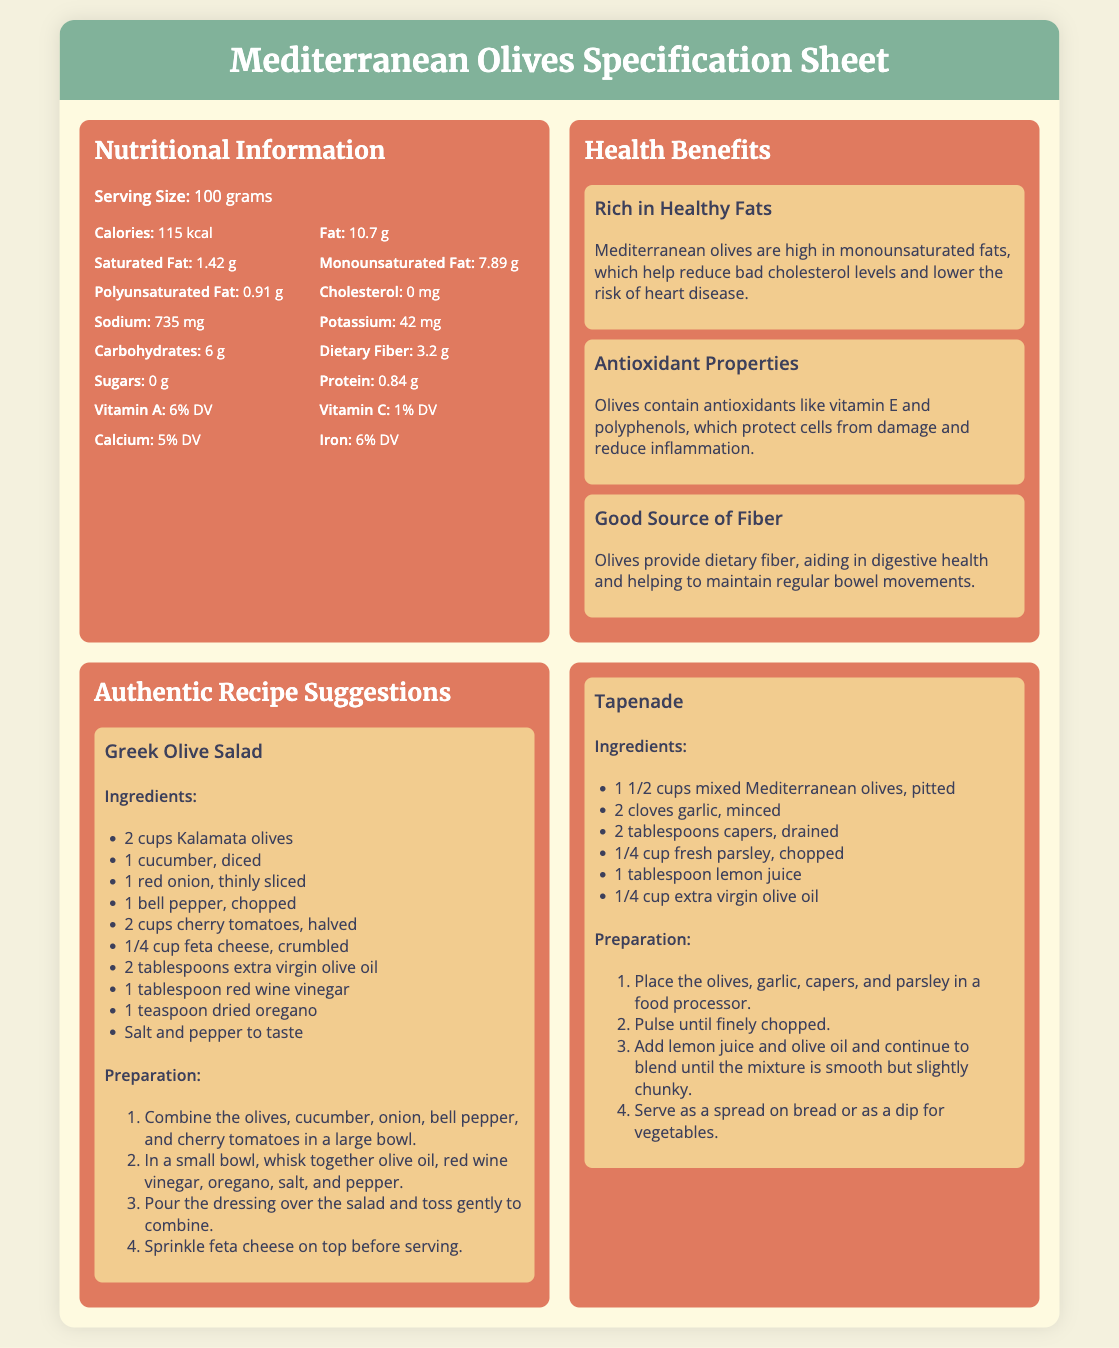what is the serving size? The serving size is specified in the document, which states it as 100 grams.
Answer: 100 grams how many calories are in 100 grams of olives? The document mentions the caloric content, which is 115 kcal per serving.
Answer: 115 kcal what is the sodium content in 100 grams of olives? The sodium content is listed in the nutritional information as 735 mg.
Answer: 735 mg what are two health benefits of Mediterranean olives? The document highlights multiple health benefits; two are reducing bad cholesterol and providing antioxidants.
Answer: Reducing bad cholesterol, providing antioxidants what is the main ingredient in Greek Olive Salad? The key ingredient is emphasized in the ingredient list, which starts with 2 cups Kalamata olives.
Answer: 2 cups Kalamata olives how many grams of protein are in 100 grams of olives? The protein content is provided in the nutritional information, noted as 0.84 g.
Answer: 0.84 g what dish requires mixed Mediterranean olives? The dish that specifically requires mixed Mediterranean olives is Tapenade.
Answer: Tapenade how many types of olives are mentioned in this specification sheet? The document includes references to two specific types: Kalamata olives and mixed Mediterranean olives.
Answer: Two types how does the document categorize information? The document is structured into categories such as Nutritional Information, Health Benefits, and Authentic Recipe Suggestions.
Answer: Nutritional Information, Health Benefits, Authentic Recipe Suggestions 